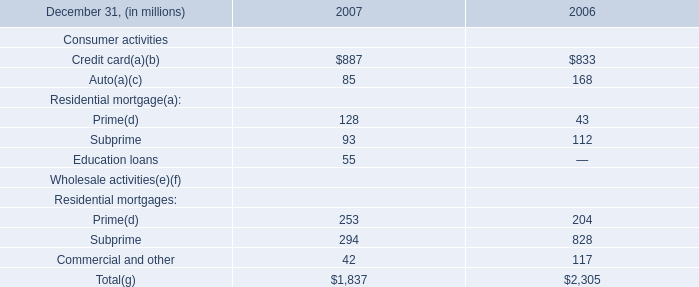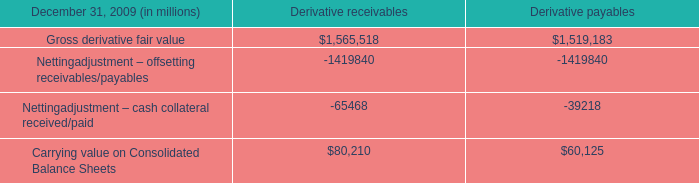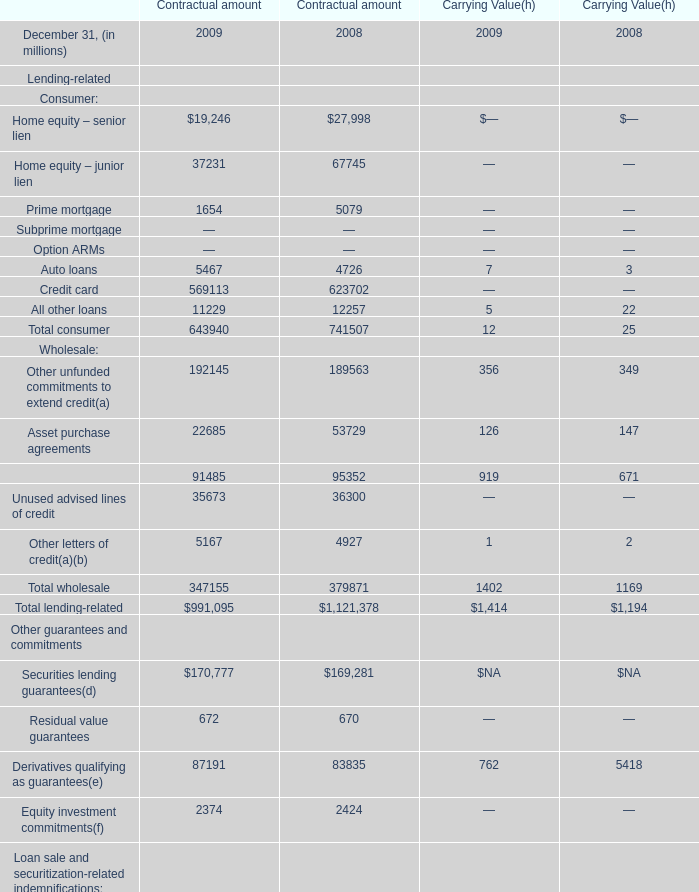at december 31 , 2009 , what was the ratio of the firm had received to the additional collateral . 
Computations: (16.9 / 5.8)
Answer: 2.91379. 